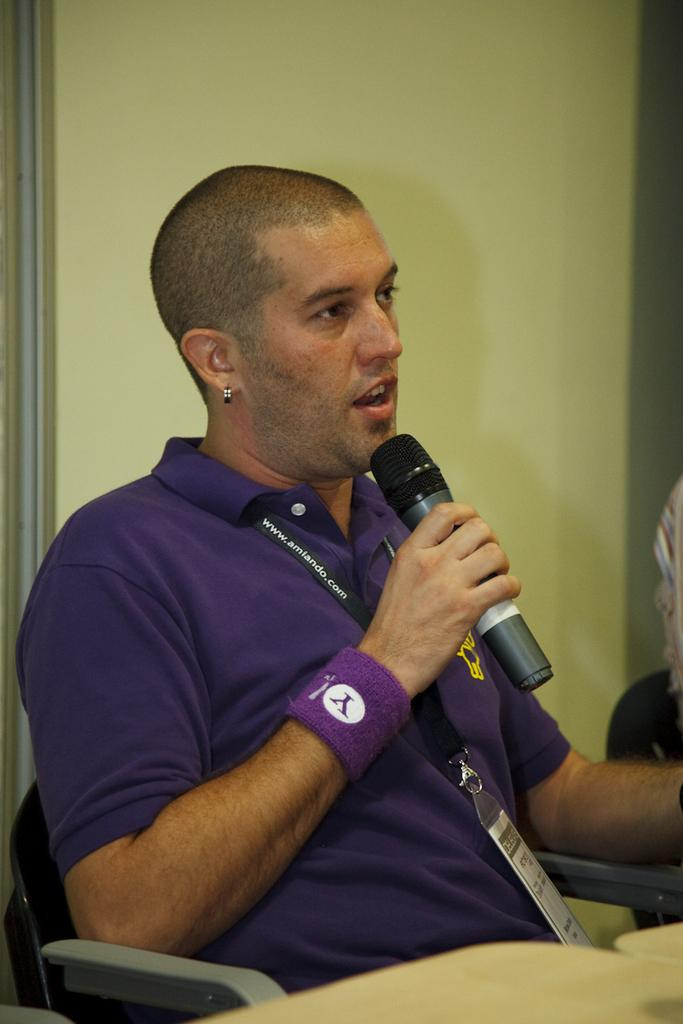Who or what is the main subject in the image? There is a person in the image. What is the person doing in the image? The person is sitting on a chair and holding a mic. What can be seen in the background of the image? There is a wall in the background of the image. What type of territory is the person claiming in the image? There is no indication of territory or any claim being made in the image; it simply shows a person sitting on a chair and holding a mic. 